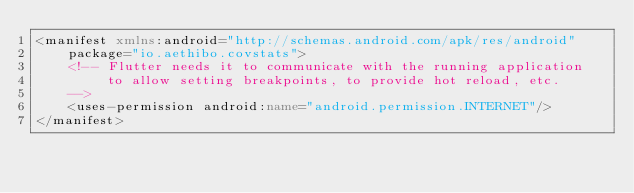<code> <loc_0><loc_0><loc_500><loc_500><_XML_><manifest xmlns:android="http://schemas.android.com/apk/res/android"
    package="io.aethibo.covstats">
    <!-- Flutter needs it to communicate with the running application
         to allow setting breakpoints, to provide hot reload, etc.
    -->
    <uses-permission android:name="android.permission.INTERNET"/>
</manifest>
</code> 